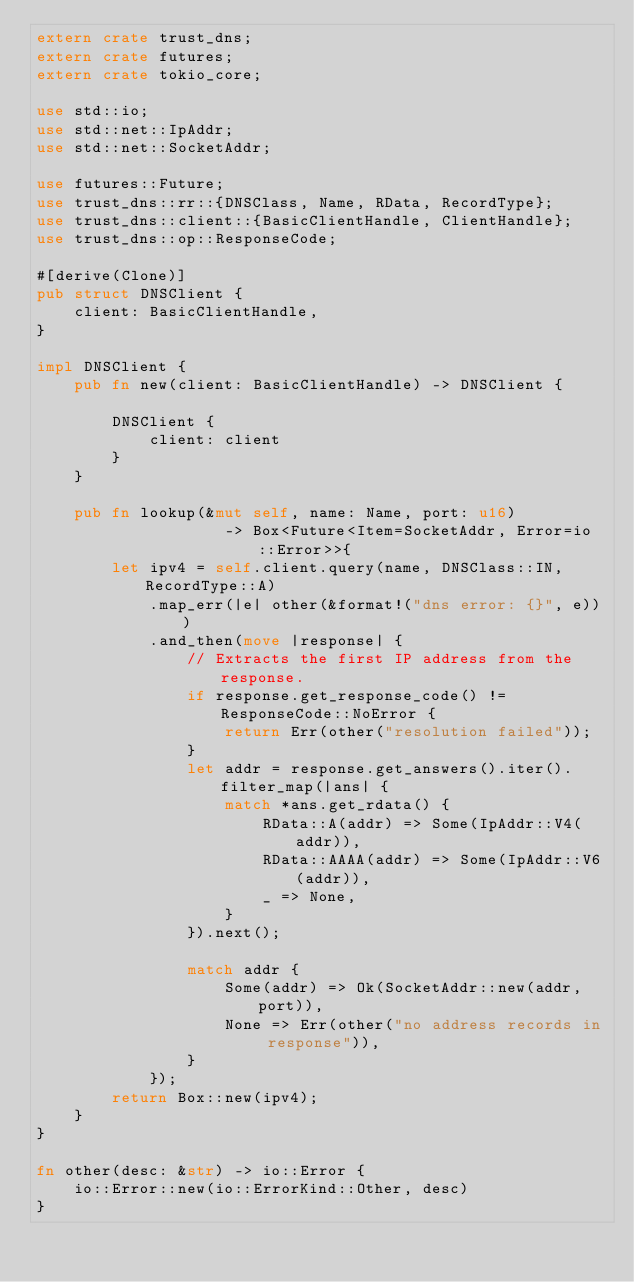Convert code to text. <code><loc_0><loc_0><loc_500><loc_500><_Rust_>extern crate trust_dns;
extern crate futures;
extern crate tokio_core;

use std::io;
use std::net::IpAddr;
use std::net::SocketAddr;

use futures::Future;
use trust_dns::rr::{DNSClass, Name, RData, RecordType};
use trust_dns::client::{BasicClientHandle, ClientHandle};
use trust_dns::op::ResponseCode;

#[derive(Clone)]
pub struct DNSClient {
    client: BasicClientHandle,
}

impl DNSClient {
    pub fn new(client: BasicClientHandle) -> DNSClient {

        DNSClient {
            client: client
        }
    }

    pub fn lookup(&mut self, name: Name, port: u16)
                    -> Box<Future<Item=SocketAddr, Error=io::Error>>{
        let ipv4 = self.client.query(name, DNSClass::IN, RecordType::A)
            .map_err(|e| other(&format!("dns error: {}", e)))
            .and_then(move |response| {
                // Extracts the first IP address from the response.
                if response.get_response_code() != ResponseCode::NoError {
                    return Err(other("resolution failed"));
                }
                let addr = response.get_answers().iter().filter_map(|ans| {
                    match *ans.get_rdata() {
                        RData::A(addr) => Some(IpAddr::V4(addr)),
                        RData::AAAA(addr) => Some(IpAddr::V6(addr)),
                        _ => None,
                    }
                }).next();

                match addr {
                    Some(addr) => Ok(SocketAddr::new(addr, port)),
                    None => Err(other("no address records in response")),
                }
            });
        return Box::new(ipv4);
    }
}

fn other(desc: &str) -> io::Error {
    io::Error::new(io::ErrorKind::Other, desc)
}
</code> 